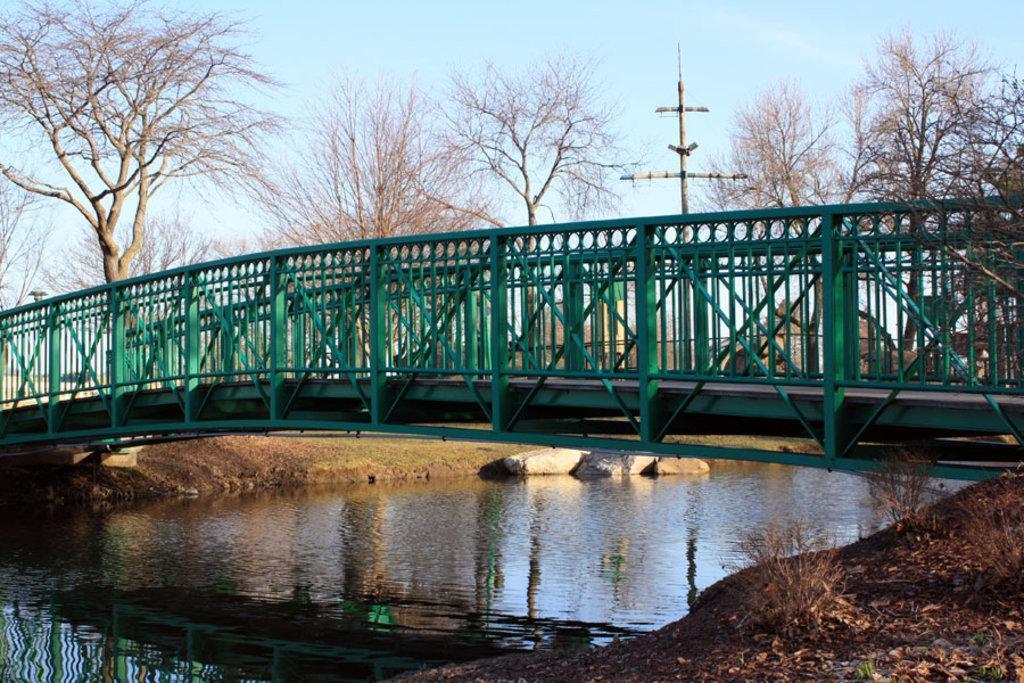Can you describe this image briefly? In this image in the center there is one bridge, at the bottom there is a lake, sand, plants, dry leaves and some rocks. In the background there are trees and pole, at the top there is sky. 